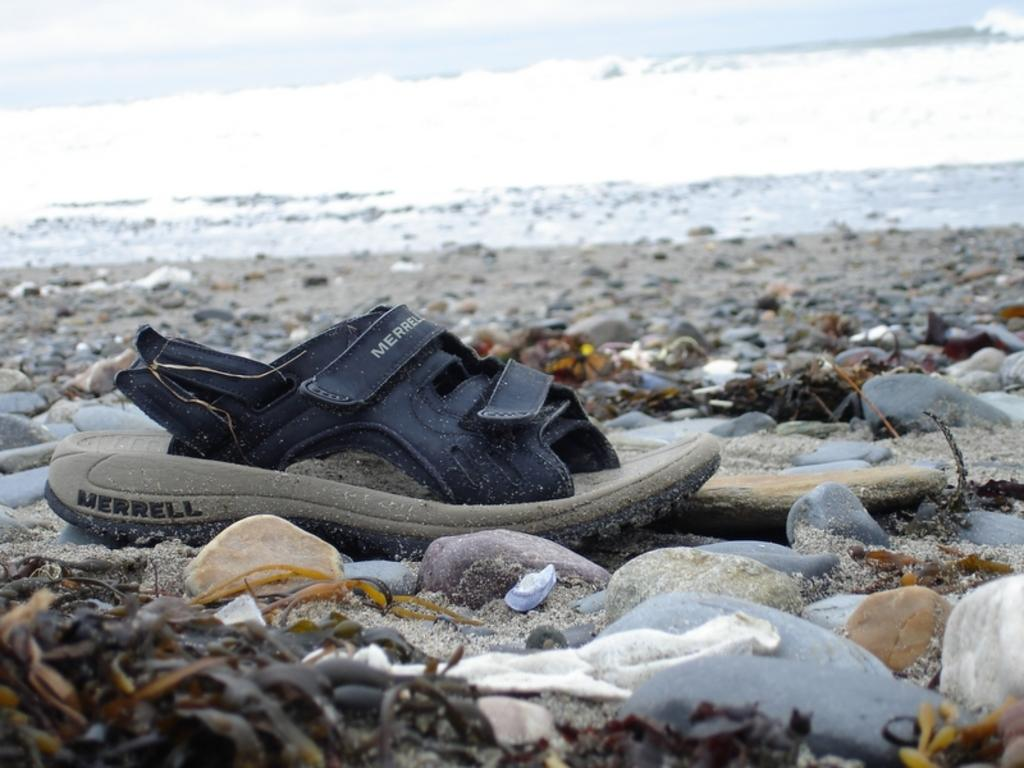What type of footwear can be seen in the image? There is footwear in the image. Can you describe the color of the footwear? The footwear is black and ash in color. What is present on the sand in the image? Rocks are present on the sand in the image. What can be seen in the distance in the image? There is water visible in the background of the image. Where is the hose connected to in the image? There is no hose present in the image. What type of range can be seen in the image? There is no range present in the image. 